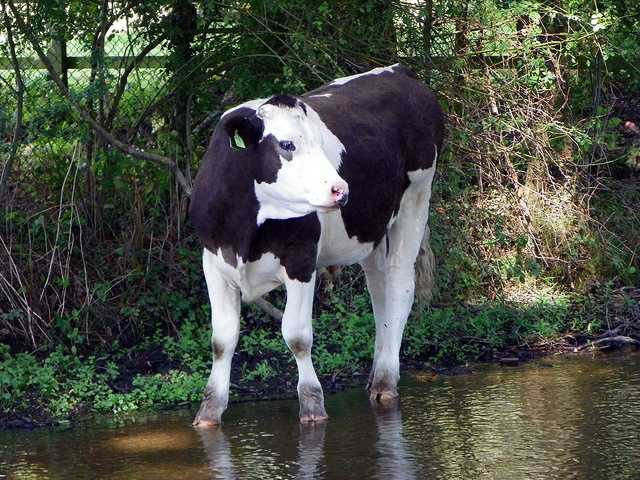Describe the objects in this image and their specific colors. I can see a cow in darkgreen, black, lightgray, darkgray, and gray tones in this image. 